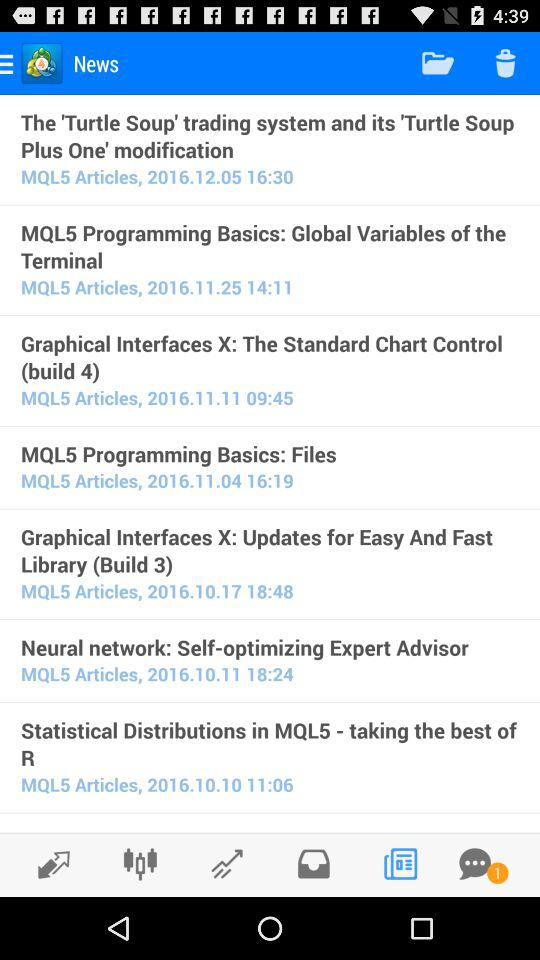How many chat notifications are there? There is 1 chat notification. 